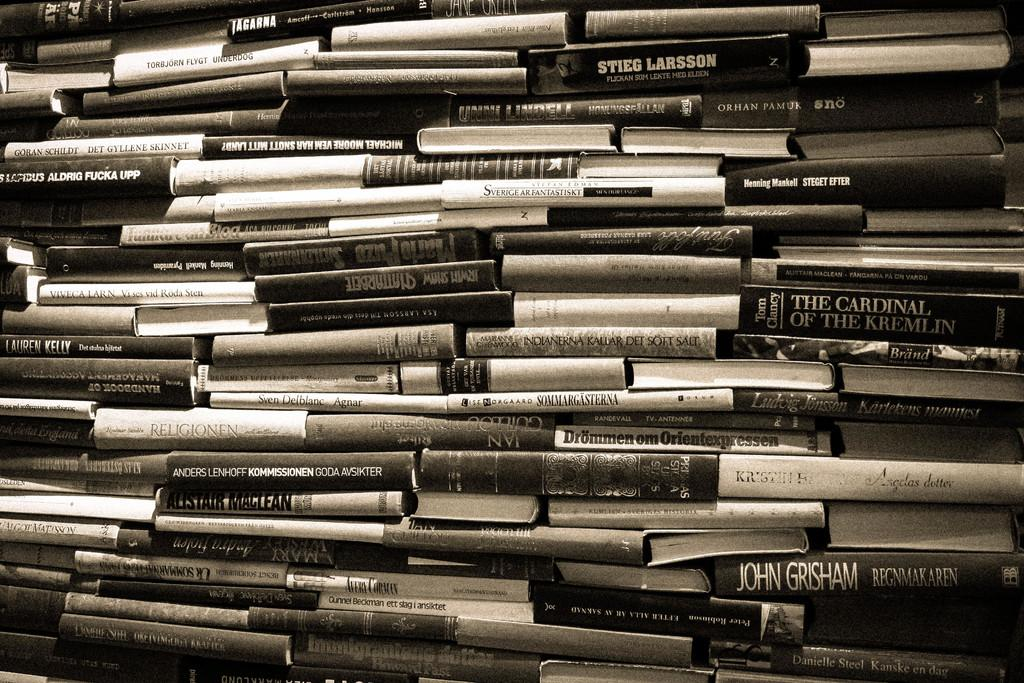Provide a one-sentence caption for the provided image. A big stack of books includes The Cardinal of the Kremlin and a John Grisham novel. 